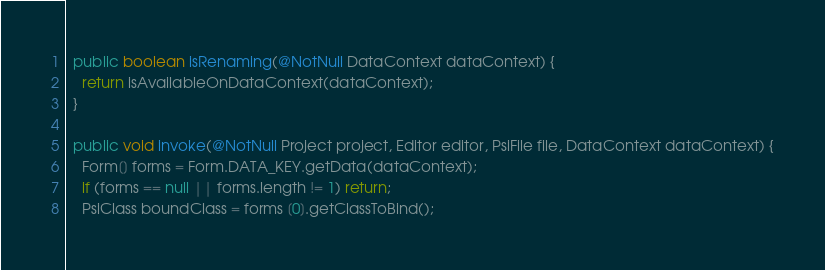<code> <loc_0><loc_0><loc_500><loc_500><_Java_>  public boolean isRenaming(@NotNull DataContext dataContext) {
    return isAvailableOnDataContext(dataContext);
  }

  public void invoke(@NotNull Project project, Editor editor, PsiFile file, DataContext dataContext) {
    Form[] forms = Form.DATA_KEY.getData(dataContext);
    if (forms == null || forms.length != 1) return;
    PsiClass boundClass = forms [0].getClassToBind();</code> 